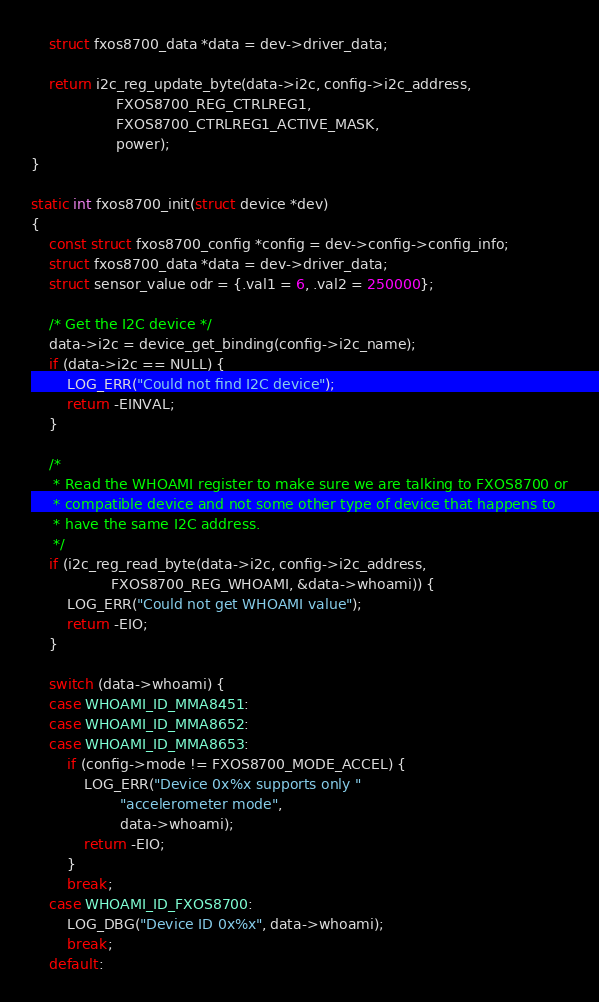Convert code to text. <code><loc_0><loc_0><loc_500><loc_500><_C_>	struct fxos8700_data *data = dev->driver_data;

	return i2c_reg_update_byte(data->i2c, config->i2c_address,
				   FXOS8700_REG_CTRLREG1,
				   FXOS8700_CTRLREG1_ACTIVE_MASK,
				   power);
}

static int fxos8700_init(struct device *dev)
{
	const struct fxos8700_config *config = dev->config->config_info;
	struct fxos8700_data *data = dev->driver_data;
	struct sensor_value odr = {.val1 = 6, .val2 = 250000};

	/* Get the I2C device */
	data->i2c = device_get_binding(config->i2c_name);
	if (data->i2c == NULL) {
		LOG_ERR("Could not find I2C device");
		return -EINVAL;
	}

	/*
	 * Read the WHOAMI register to make sure we are talking to FXOS8700 or
	 * compatible device and not some other type of device that happens to
	 * have the same I2C address.
	 */
	if (i2c_reg_read_byte(data->i2c, config->i2c_address,
			      FXOS8700_REG_WHOAMI, &data->whoami)) {
		LOG_ERR("Could not get WHOAMI value");
		return -EIO;
	}

	switch (data->whoami) {
	case WHOAMI_ID_MMA8451:
	case WHOAMI_ID_MMA8652:
	case WHOAMI_ID_MMA8653:
		if (config->mode != FXOS8700_MODE_ACCEL) {
			LOG_ERR("Device 0x%x supports only "
				    "accelerometer mode",
				    data->whoami);
			return -EIO;
		}
		break;
	case WHOAMI_ID_FXOS8700:
		LOG_DBG("Device ID 0x%x", data->whoami);
		break;
	default:</code> 